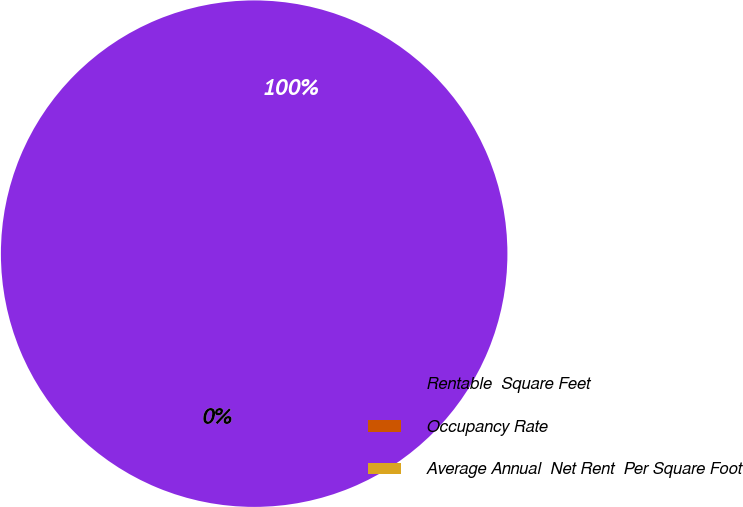Convert chart. <chart><loc_0><loc_0><loc_500><loc_500><pie_chart><fcel>Rentable  Square Feet<fcel>Occupancy Rate<fcel>Average Annual  Net Rent  Per Square Foot<nl><fcel>100.0%<fcel>0.0%<fcel>0.0%<nl></chart> 